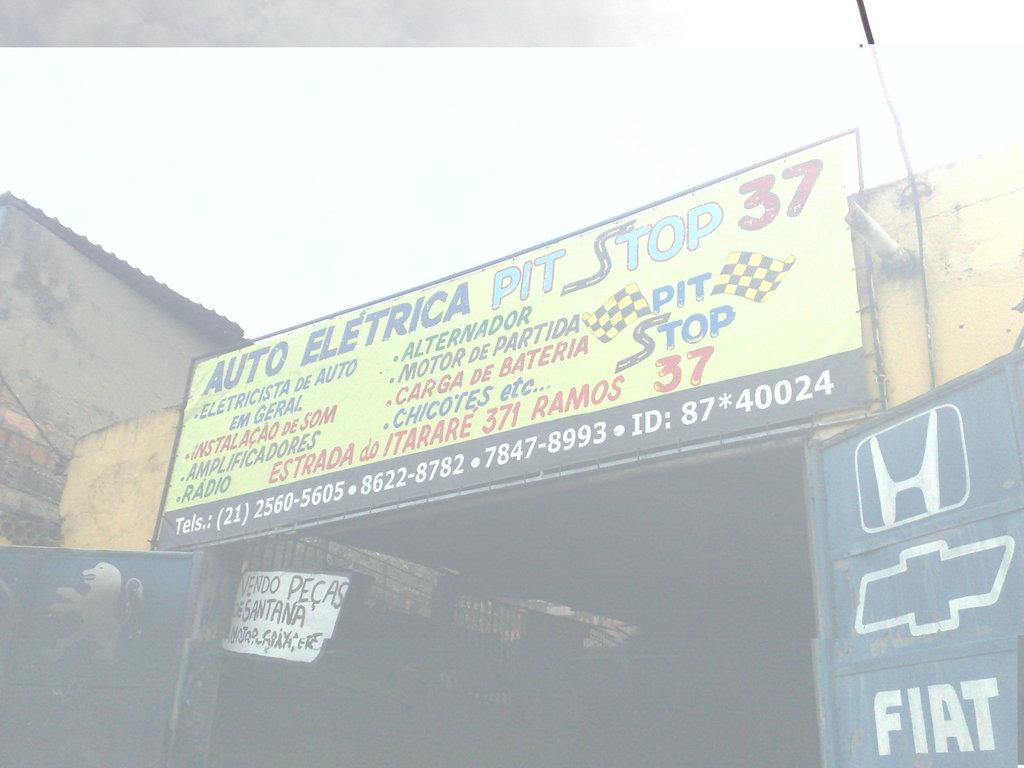Provide a one-sentence caption for the provided image. A sign for Auto Electrica Pit Stop 37 sits above a walkway. 